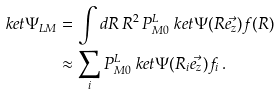Convert formula to latex. <formula><loc_0><loc_0><loc_500><loc_500>\ k e t { \Psi _ { L M } } & = \int d R \, R ^ { 2 } \, P ^ { L } _ { M 0 } \ k e t { \Psi ( R \vec { e _ { z } } ) } f ( R ) \\ & \approx \sum _ { i } P ^ { L } _ { M 0 } \ k e t { \Psi ( R _ { i } \vec { e _ { z } } ) } f _ { i } \, .</formula> 